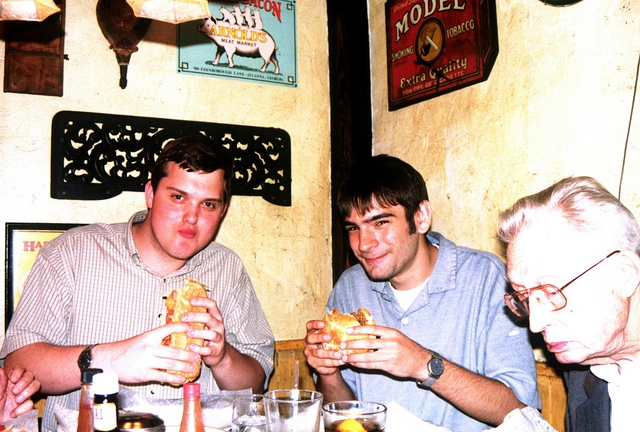Describe the objects in this image and their specific colors. I can see people in orange, lavender, lightpink, salmon, and black tones, people in orange, lavender, salmon, and black tones, people in orange, white, lightpink, black, and gray tones, hot dog in orange, white, khaki, and lightpink tones, and cup in orange, lavender, darkgray, and gray tones in this image. 